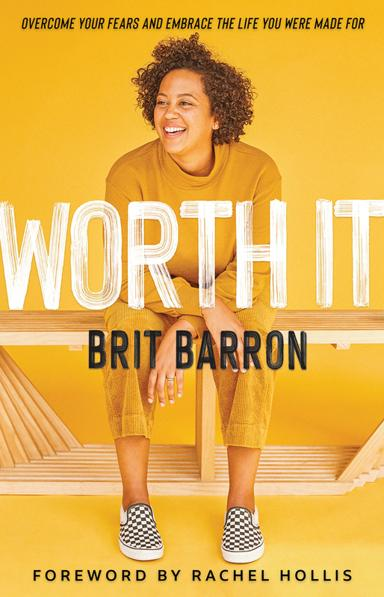Can you explain the significance of the book's cover design? The cover design of 'Worth It' with its bold yellow background and Brit Barron's joyful expression plays a crucial role in conveying the book's optimistic and empowering message. The color yellow often symbolizes positivity and energy, which aligns with the book's themes of personal empowerment and joyful living. 